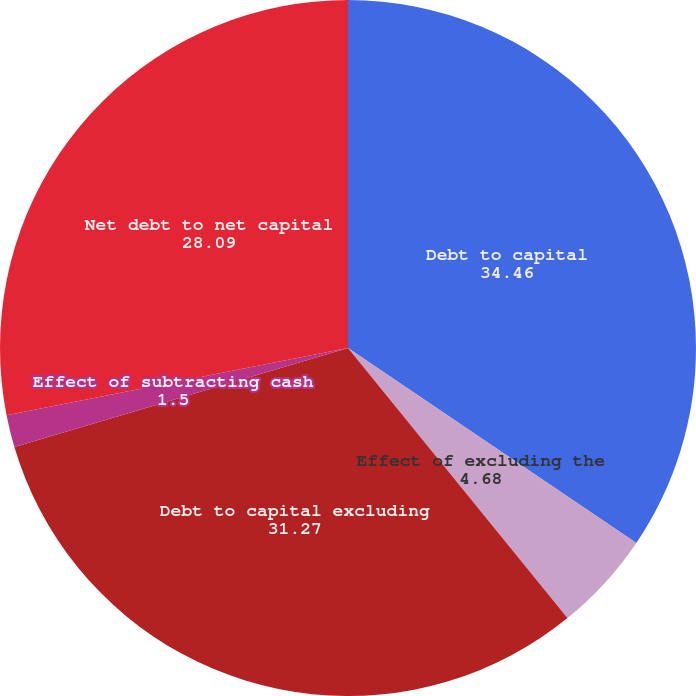Convert chart. <chart><loc_0><loc_0><loc_500><loc_500><pie_chart><fcel>Debt to capital<fcel>Effect of excluding the<fcel>Debt to capital excluding<fcel>Effect of subtracting cash<fcel>Net debt to net capital<nl><fcel>34.46%<fcel>4.68%<fcel>31.27%<fcel>1.5%<fcel>28.09%<nl></chart> 